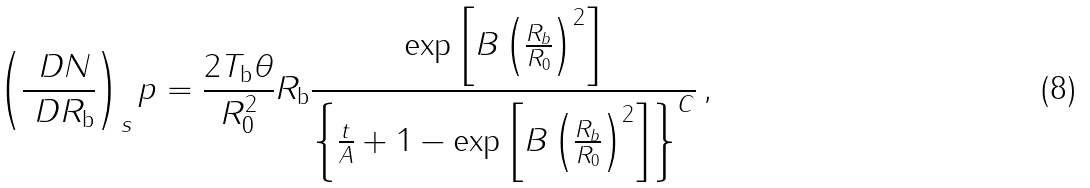<formula> <loc_0><loc_0><loc_500><loc_500>\left ( \frac { \ D N } { \ D R _ { \mathrm b } } \right ) _ { s } p = \frac { 2 T _ { \mathrm b } \theta } { R _ { 0 } ^ { 2 } } R _ { \mathrm b } \frac { \exp \left [ B \left ( \frac { R _ { b } } { R _ { 0 } } \right ) ^ { 2 } \right ] } { \left \{ \frac { t } { A } + 1 - \exp \left [ B \left ( \frac { R _ { b } } { R _ { 0 } } \right ) ^ { 2 } \right ] \right \} ^ { C } } \, ,</formula> 